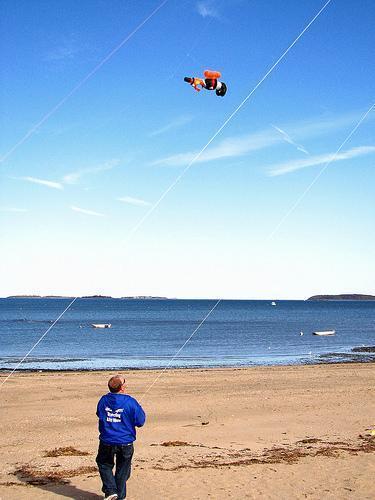How many people are in the photo?
Give a very brief answer. 1. 